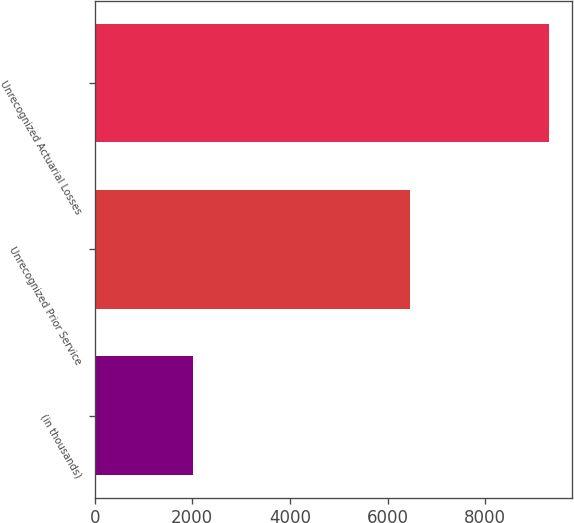<chart> <loc_0><loc_0><loc_500><loc_500><bar_chart><fcel>(in thousands)<fcel>Unrecognized Prior Service<fcel>Unrecognized Actuarial Losses<nl><fcel>2018<fcel>6461<fcel>9302<nl></chart> 